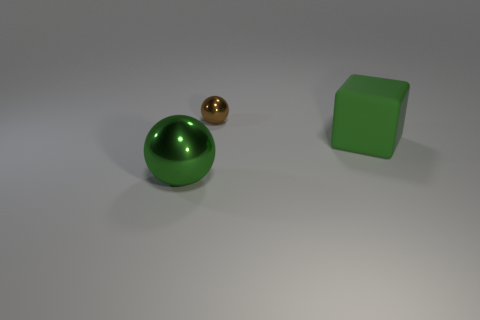Add 1 large matte cubes. How many objects exist? 4 Subtract 0 purple spheres. How many objects are left? 3 Subtract all cubes. How many objects are left? 2 Subtract all green blocks. Subtract all shiny objects. How many objects are left? 0 Add 2 matte cubes. How many matte cubes are left? 3 Add 1 shiny things. How many shiny things exist? 3 